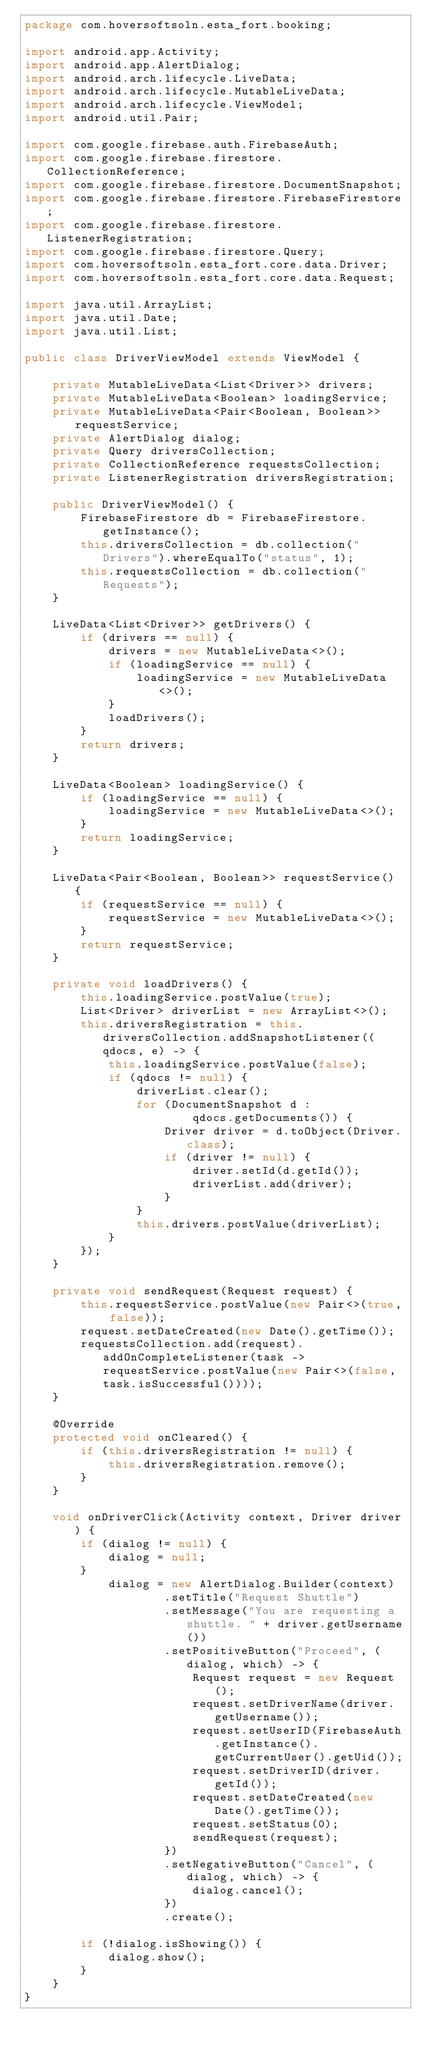<code> <loc_0><loc_0><loc_500><loc_500><_Java_>package com.hoversoftsoln.esta_fort.booking;

import android.app.Activity;
import android.app.AlertDialog;
import android.arch.lifecycle.LiveData;
import android.arch.lifecycle.MutableLiveData;
import android.arch.lifecycle.ViewModel;
import android.util.Pair;

import com.google.firebase.auth.FirebaseAuth;
import com.google.firebase.firestore.CollectionReference;
import com.google.firebase.firestore.DocumentSnapshot;
import com.google.firebase.firestore.FirebaseFirestore;
import com.google.firebase.firestore.ListenerRegistration;
import com.google.firebase.firestore.Query;
import com.hoversoftsoln.esta_fort.core.data.Driver;
import com.hoversoftsoln.esta_fort.core.data.Request;

import java.util.ArrayList;
import java.util.Date;
import java.util.List;

public class DriverViewModel extends ViewModel {

    private MutableLiveData<List<Driver>> drivers;
    private MutableLiveData<Boolean> loadingService;
    private MutableLiveData<Pair<Boolean, Boolean>> requestService;
    private AlertDialog dialog;
    private Query driversCollection;
    private CollectionReference requestsCollection;
    private ListenerRegistration driversRegistration;

    public DriverViewModel() {
        FirebaseFirestore db = FirebaseFirestore.getInstance();
        this.driversCollection = db.collection("Drivers").whereEqualTo("status", 1);
        this.requestsCollection = db.collection("Requests");
    }

    LiveData<List<Driver>> getDrivers() {
        if (drivers == null) {
            drivers = new MutableLiveData<>();
            if (loadingService == null) {
                loadingService = new MutableLiveData<>();
            }
            loadDrivers();
        }
        return drivers;
    }

    LiveData<Boolean> loadingService() {
        if (loadingService == null) {
            loadingService = new MutableLiveData<>();
        }
        return loadingService;
    }

    LiveData<Pair<Boolean, Boolean>> requestService() {
        if (requestService == null) {
            requestService = new MutableLiveData<>();
        }
        return requestService;
    }

    private void loadDrivers() {
        this.loadingService.postValue(true);
        List<Driver> driverList = new ArrayList<>();
        this.driversRegistration = this.driversCollection.addSnapshotListener((qdocs, e) -> {
            this.loadingService.postValue(false);
            if (qdocs != null) {
                driverList.clear();
                for (DocumentSnapshot d :
                        qdocs.getDocuments()) {
                    Driver driver = d.toObject(Driver.class);
                    if (driver != null) {
                        driver.setId(d.getId());
                        driverList.add(driver);
                    }
                }
                this.drivers.postValue(driverList);
            }
        });
    }

    private void sendRequest(Request request) {
        this.requestService.postValue(new Pair<>(true, false));
        request.setDateCreated(new Date().getTime());
        requestsCollection.add(request).addOnCompleteListener(task -> requestService.postValue(new Pair<>(false, task.isSuccessful())));
    }

    @Override
    protected void onCleared() {
        if (this.driversRegistration != null) {
            this.driversRegistration.remove();
        }
    }

    void onDriverClick(Activity context, Driver driver) {
        if (dialog != null) {
            dialog = null;
        }
            dialog = new AlertDialog.Builder(context)
                    .setTitle("Request Shuttle")
                    .setMessage("You are requesting a shuttle. " + driver.getUsername())
                    .setPositiveButton("Proceed", (dialog, which) -> {
                        Request request = new Request();
                        request.setDriverName(driver.getUsername());
                        request.setUserID(FirebaseAuth.getInstance().getCurrentUser().getUid());
                        request.setDriverID(driver.getId());
                        request.setDateCreated(new Date().getTime());
                        request.setStatus(0);
                        sendRequest(request);
                    })
                    .setNegativeButton("Cancel", (dialog, which) -> {
                        dialog.cancel();
                    })
                    .create();

        if (!dialog.isShowing()) {
            dialog.show();
        }
    }
}
</code> 